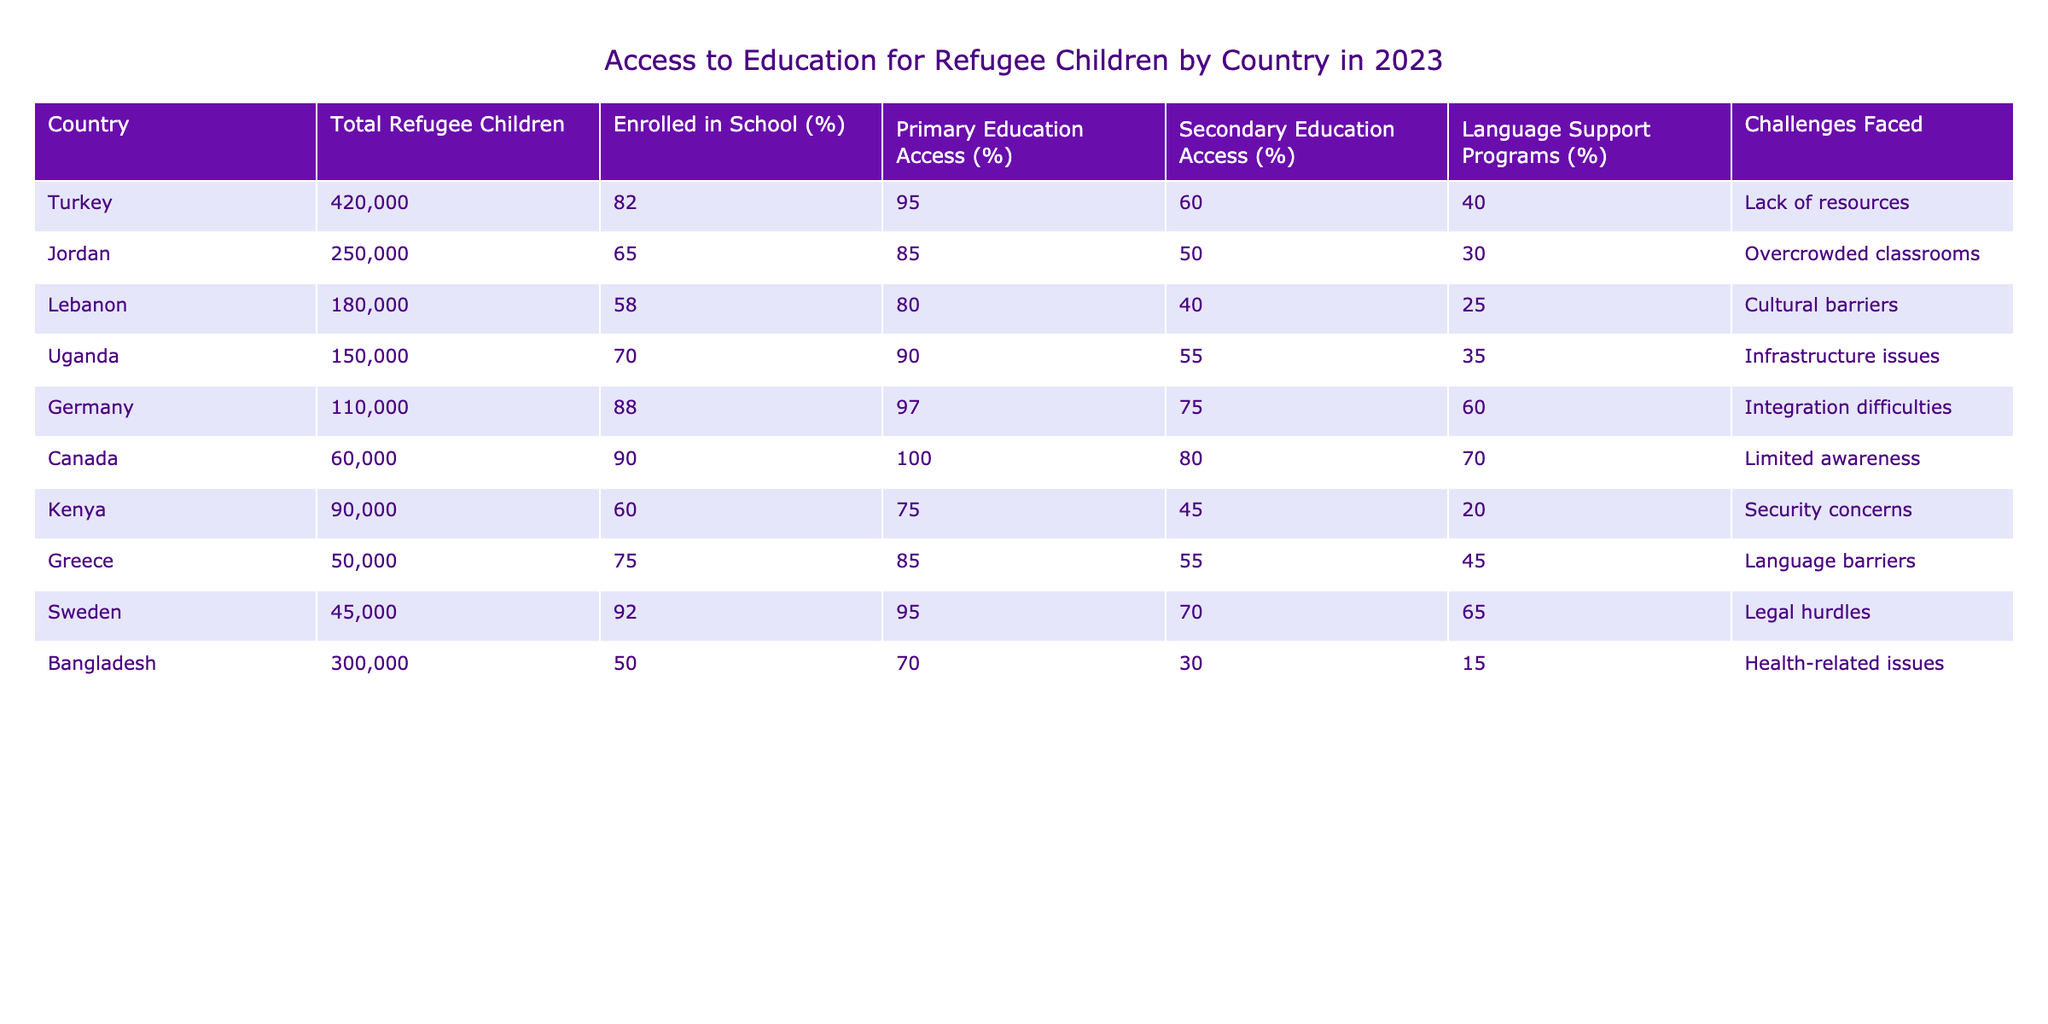What percentage of refugee children in Germany are enrolled in school? According to the table, the percentage of refugee children in Germany who are enrolled in school is specified as 88%.
Answer: 88% Which country has the lowest percentage of access to secondary education for refugee children? By comparing the percentages under the Secondary Education Access column, we find that Bangladesh has the lowest percentage at 30%.
Answer: Bangladesh What is the average percentage of primary education access among the listed countries? To find the average, we sum the percentages of primary education access: (95 + 85 + 80 + 90 + 97 + 100 + 75 + 85 + 95 + 70) = 927. Since there are 10 countries, the average is 927/10 = 92.7%.
Answer: 92.7% Is it true that Kenya has more refugees enrolled in school than Uganda? From the table, Kenya has 60% enrolled in school, while Uganda has 70%. Therefore, the statement is false.
Answer: No Which countries have language support programs available for more than 50% of refugee children? Examining the Language Support Programs column, the countries with more than 50% are Canada (70%), Germany (60%), and Sweden (65%).
Answer: Canada, Germany, Sweden What is the difference in the percentage of school enrollment between Turkey and Lebanon? Turkey's school enrollment percentage is 82% while Lebanon's is 58%. The difference is calculated as 82% - 58% = 24%.
Answer: 24% Which country faces cultural barriers as a significant challenge to education? The table indicates that Lebanon faces cultural barriers as a significant challenge to education.
Answer: Lebanon What is the total number of refugee children enrolled in school across all listed countries? To find this, we can total the numbers of refugee children and their corresponding enrollment percentages: (420000 * 0.82 + 250000 * 0.65 + 180000 * 0.58 + 150000 * 0.70 + 110000 * 0.88 + 60000 * 0.90 + 90000 * 0.60 + 50000 * 0.75 + 45000 * 0.92 + 300000 * 0.50) = 397,600 children enrolled in school.
Answer: 397600 What is the highest percentage of primary education access and which country provides it? The highest percentage of primary education access is 100%, and this is provided by Canada.
Answer: Canada 